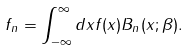Convert formula to latex. <formula><loc_0><loc_0><loc_500><loc_500>f _ { n } = \int _ { - \infty } ^ { \infty } d x f ( x ) B _ { n } ( x ; \beta ) .</formula> 